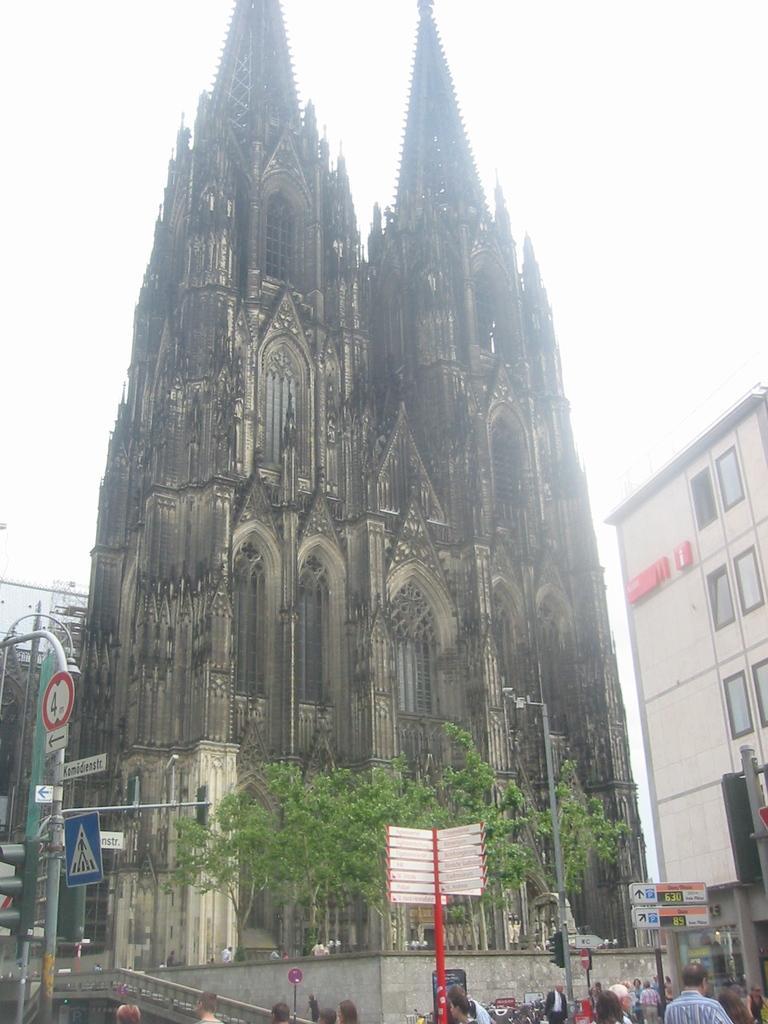Please provide a concise description of this image. In this image I can see buildings , in front of buildings I can see trees, persons, sign boards, poles, at the top there is the sky and there is a tower visible in the middle. 